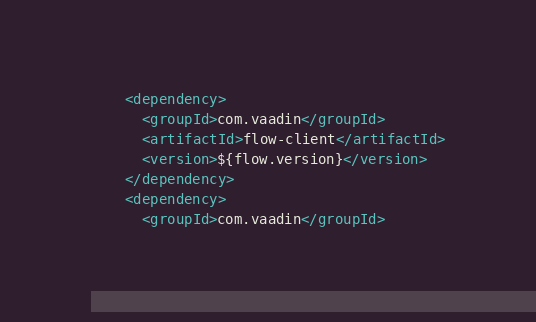Convert code to text. <code><loc_0><loc_0><loc_500><loc_500><_XML_>    <dependency>
      <groupId>com.vaadin</groupId>
      <artifactId>flow-client</artifactId>
      <version>${flow.version}</version>
    </dependency>
    <dependency>
      <groupId>com.vaadin</groupId></code> 